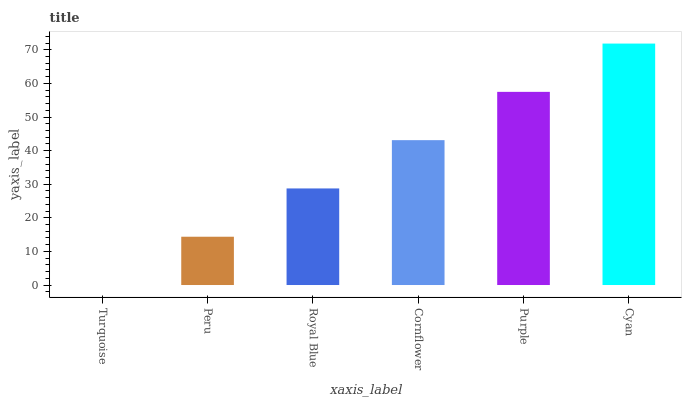Is Turquoise the minimum?
Answer yes or no. Yes. Is Cyan the maximum?
Answer yes or no. Yes. Is Peru the minimum?
Answer yes or no. No. Is Peru the maximum?
Answer yes or no. No. Is Peru greater than Turquoise?
Answer yes or no. Yes. Is Turquoise less than Peru?
Answer yes or no. Yes. Is Turquoise greater than Peru?
Answer yes or no. No. Is Peru less than Turquoise?
Answer yes or no. No. Is Cornflower the high median?
Answer yes or no. Yes. Is Royal Blue the low median?
Answer yes or no. Yes. Is Turquoise the high median?
Answer yes or no. No. Is Cornflower the low median?
Answer yes or no. No. 